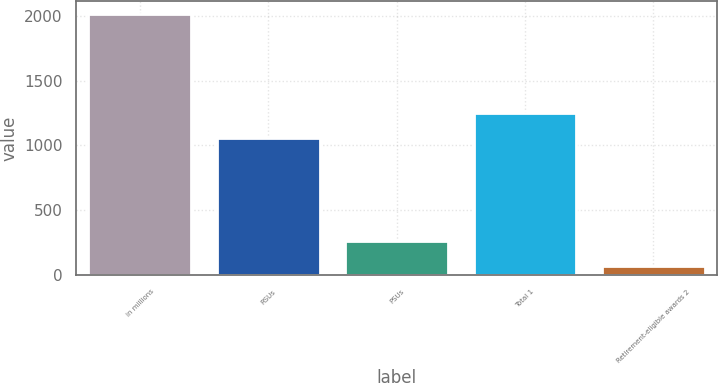Convert chart to OTSL. <chart><loc_0><loc_0><loc_500><loc_500><bar_chart><fcel>in millions<fcel>RSUs<fcel>PSUs<fcel>Total 1<fcel>Retirement-eligible awards 2<nl><fcel>2016<fcel>1054<fcel>267.3<fcel>1248.3<fcel>73<nl></chart> 